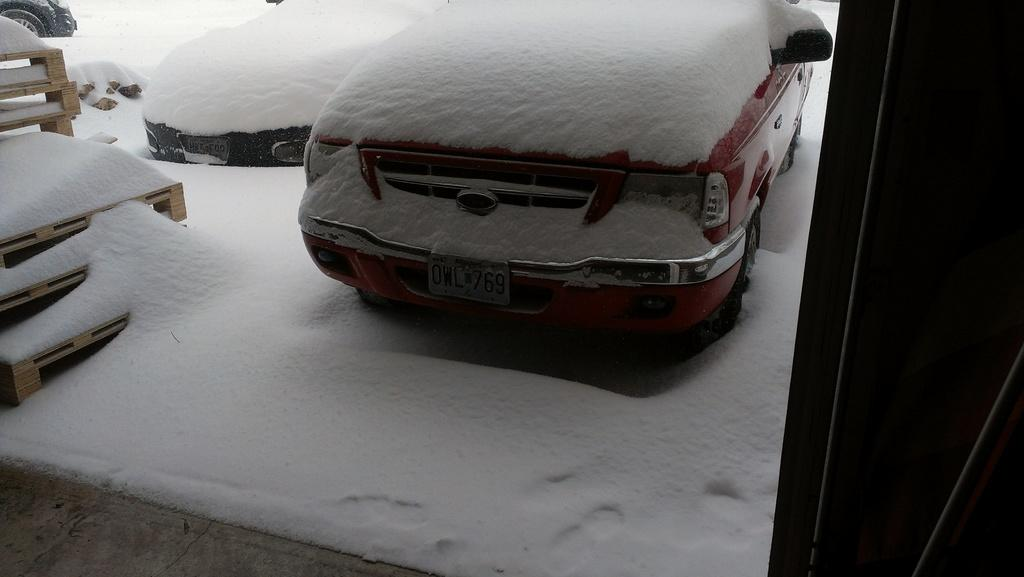What is the condition of the vehicles in the image? The vehicles in the image are covered with snow. What can be seen on the left side of the image? There is an object that looks like a staircase on the left side of the image. How would you describe the lighting on the right side of the image? The right side of the image is dark. Can you tell me how many cushions are on the trail in the image? There is no trail or cushions present in the image; it features vehicles covered with snow and a possible staircase-like object on the left side. 